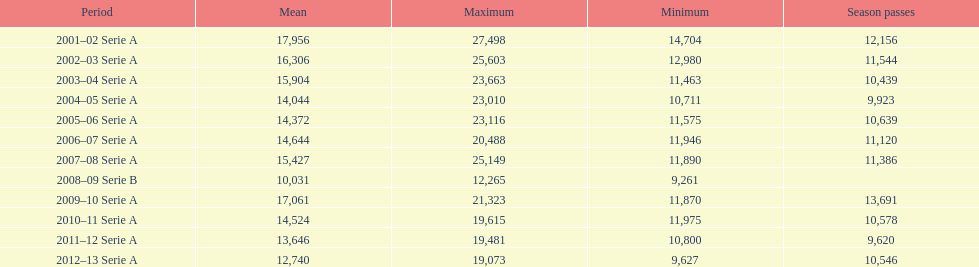How many seasons had average attendance of at least 15,000 at the stadio ennio tardini? 5. 